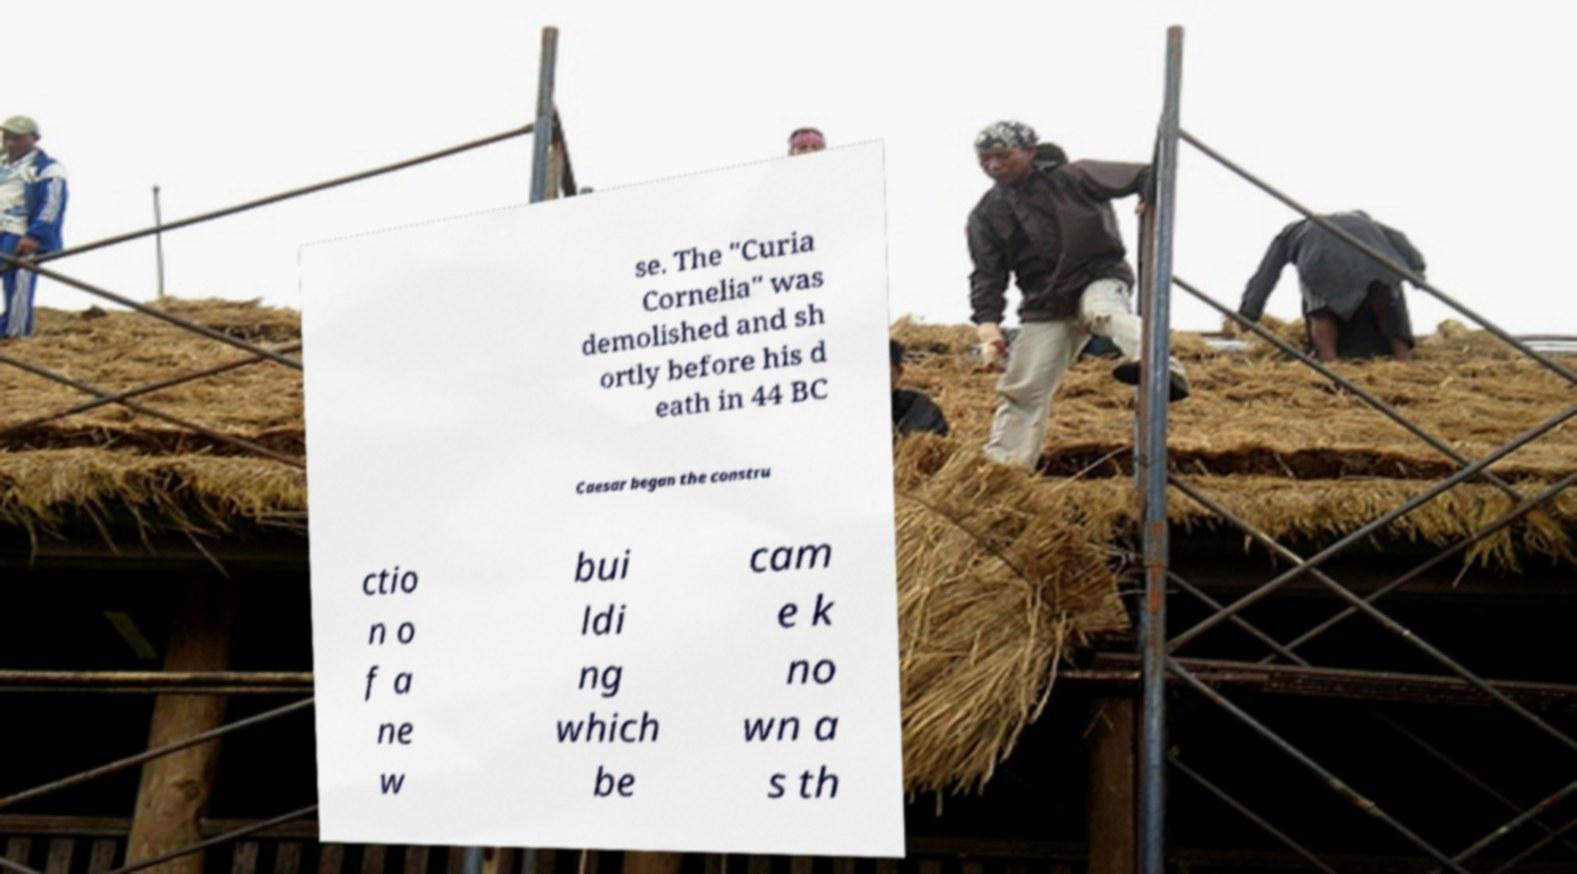What messages or text are displayed in this image? I need them in a readable, typed format. se. The "Curia Cornelia" was demolished and sh ortly before his d eath in 44 BC Caesar began the constru ctio n o f a ne w bui ldi ng which be cam e k no wn a s th 